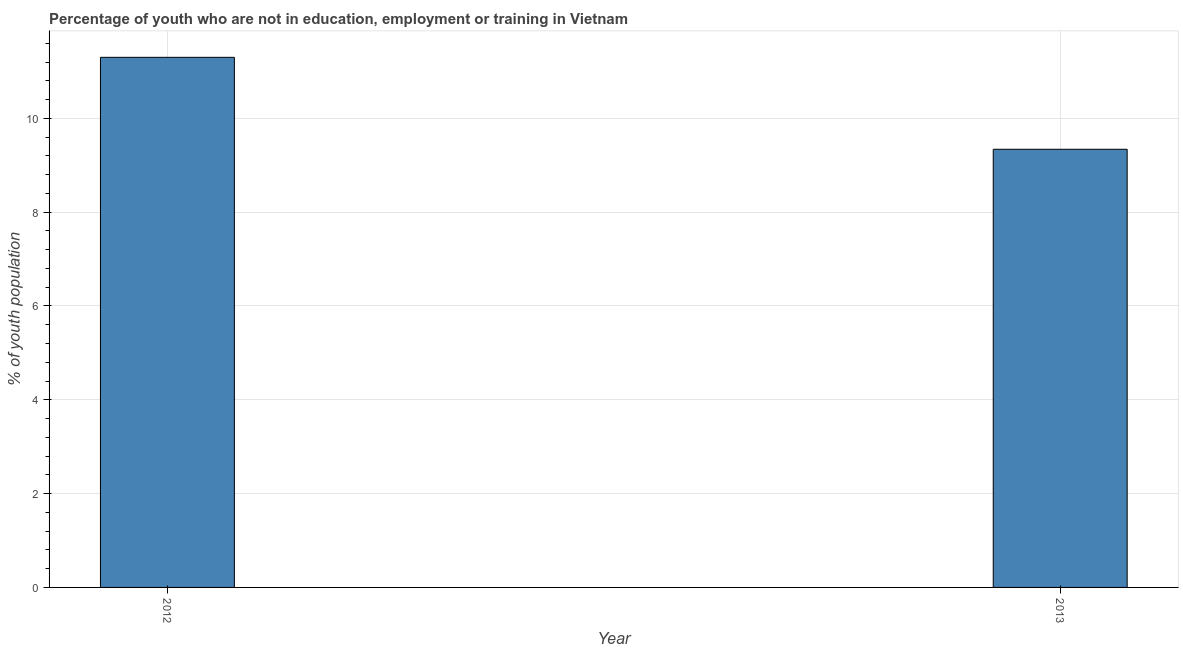Does the graph contain any zero values?
Offer a terse response. No. What is the title of the graph?
Keep it short and to the point. Percentage of youth who are not in education, employment or training in Vietnam. What is the label or title of the Y-axis?
Keep it short and to the point. % of youth population. What is the unemployed youth population in 2013?
Keep it short and to the point. 9.34. Across all years, what is the maximum unemployed youth population?
Provide a short and direct response. 11.3. Across all years, what is the minimum unemployed youth population?
Provide a succinct answer. 9.34. What is the sum of the unemployed youth population?
Your answer should be compact. 20.64. What is the difference between the unemployed youth population in 2012 and 2013?
Your answer should be very brief. 1.96. What is the average unemployed youth population per year?
Offer a terse response. 10.32. What is the median unemployed youth population?
Keep it short and to the point. 10.32. Do a majority of the years between 2013 and 2012 (inclusive) have unemployed youth population greater than 2.8 %?
Keep it short and to the point. No. What is the ratio of the unemployed youth population in 2012 to that in 2013?
Make the answer very short. 1.21. Is the unemployed youth population in 2012 less than that in 2013?
Offer a very short reply. No. In how many years, is the unemployed youth population greater than the average unemployed youth population taken over all years?
Offer a terse response. 1. What is the % of youth population in 2012?
Your answer should be compact. 11.3. What is the % of youth population of 2013?
Your response must be concise. 9.34. What is the difference between the % of youth population in 2012 and 2013?
Ensure brevity in your answer.  1.96. What is the ratio of the % of youth population in 2012 to that in 2013?
Keep it short and to the point. 1.21. 